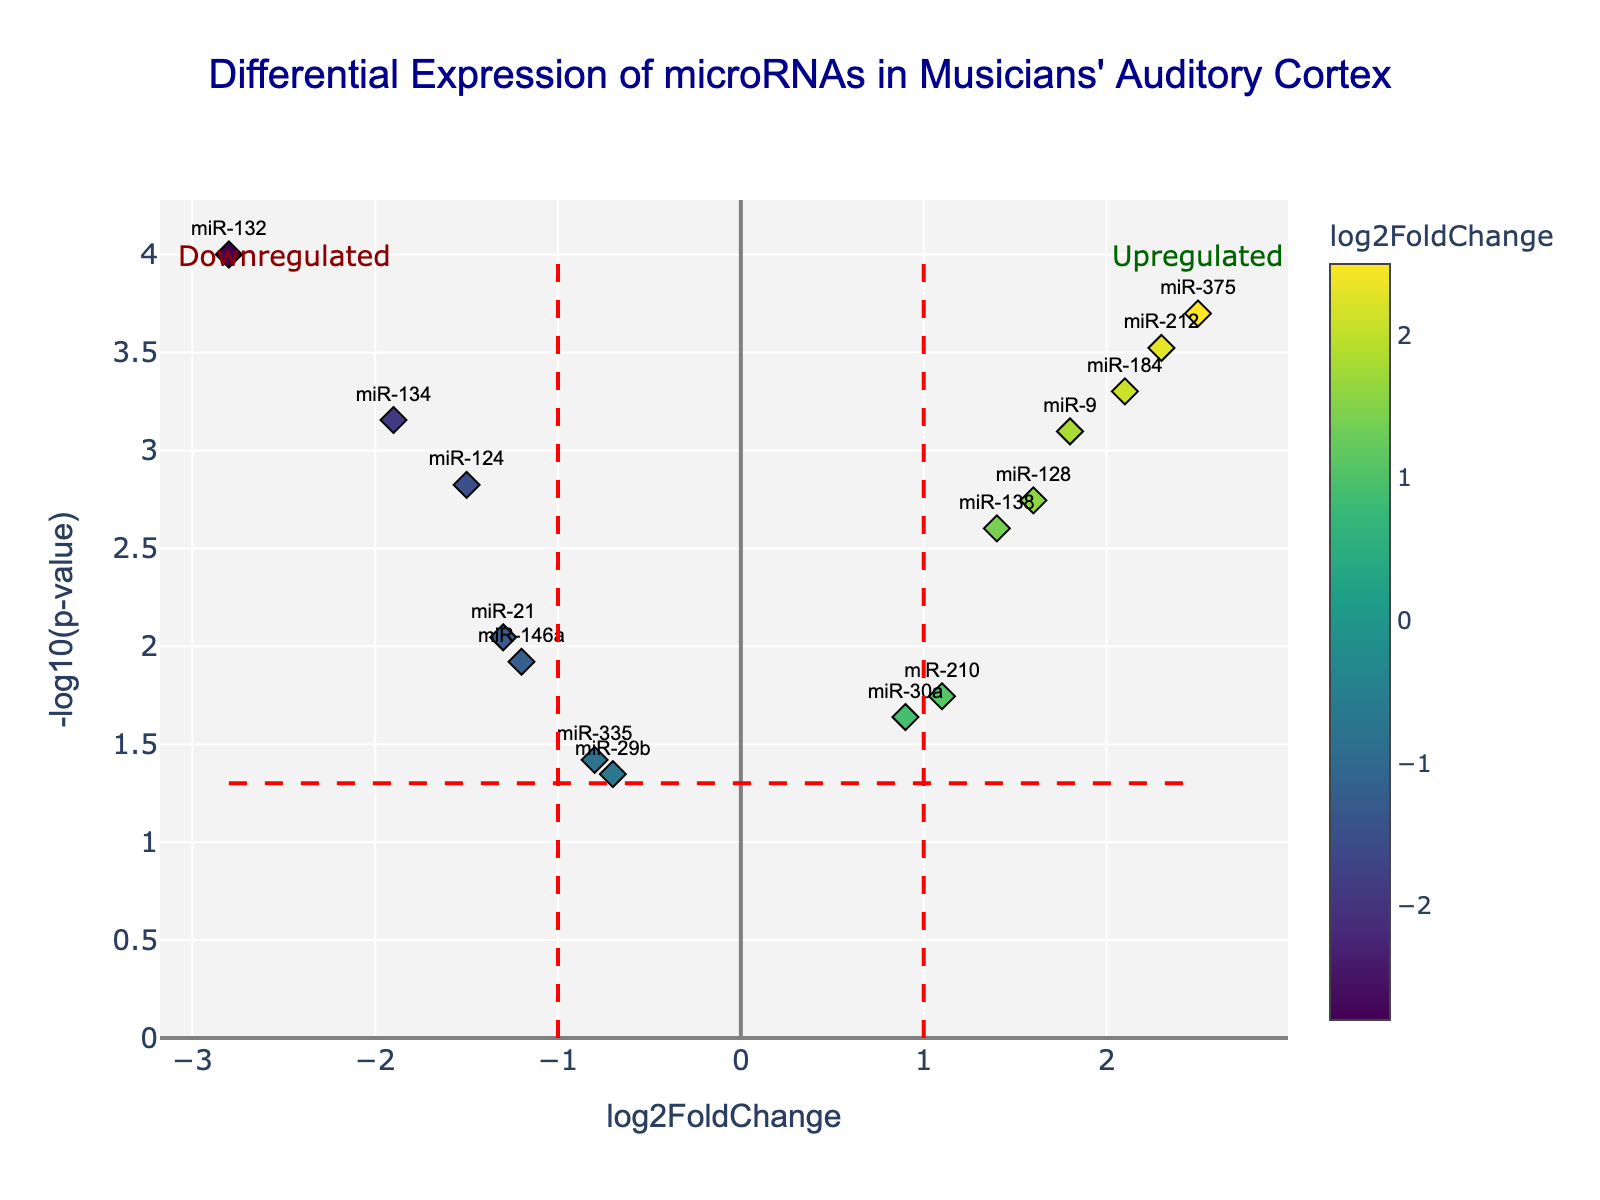What is the title of this plot? The title is usually placed at the top of the plot and provides a summary of what the plot represents. By looking at the top of the figure, we can see the title clearly.
Answer: Differential Expression of microRNAs in Musicians' Auditory Cortex How many microRNAs have a log2 fold change greater than 1? To find this, look at the x-axis of the plot where log2 fold change is displayed and count all data points (markers) to the right of the vertical line at x=1. These points represent microRNAs with log2 fold change greater than 1.
Answer: 5 Which microRNA has the highest -log10(p-value)? The -log10(p-value) is shown on the y-axis. The microRNA with the highest value will be the marker positioned at the topmost part of the plot.
Answer: miR-132 Are there more upregulated or downregulated microRNAs? Upregulated microRNAs have positive log2 fold change values (to the right of x=0), while downregulated have negative values (to the left of x=0). Count both sides to compare.
Answer: More upregulated (7 vs. 6) What is the log2 fold change of miR-375? Locate the marker labeled "miR-375" on the plot. The value on the x-axis at this point is the log2 fold change.
Answer: 2.5 How many microRNAs have a p-value less than 0.05? The -log10(p-value) for 0.05 is shown by the horizontal dashed red line. Count all markers above this line to find the number of microRNAs with p-values less than 0.05.
Answer: 10 Which microRNA has the lowest log2 fold change and what is its value? The lowest log2 fold change will be the data point furthest to the left on the x-axis. Identify the label and the log2 fold change value.
Answer: miR-132, -2.8 Between miR-134 and miR-124, which has a more significant p-value? A more significant p-value corresponds to a higher -log10(p-value). Compare the y-axis positions of miR-134 and miR-124 to find which one is higher.
Answer: miR-134 What color represents the datapoint with miR-212 and why? The color scale indicates log2 fold change values. Find the color of miR-212 and relate it to the color bar scale to explain its log2 fold change.
Answer: It is a color representing 2.3 on the color scale, towards the greener region 